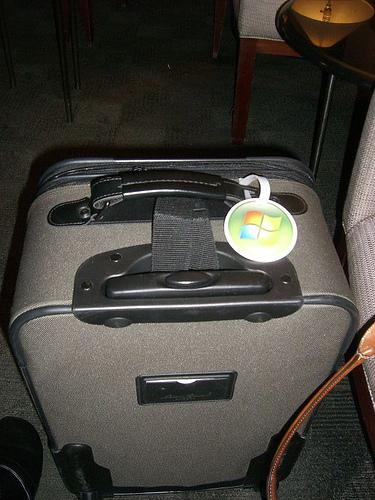How many colors in Microsoft Windows logo? Please explain your reasoning. four. There are four colors on the logo. 